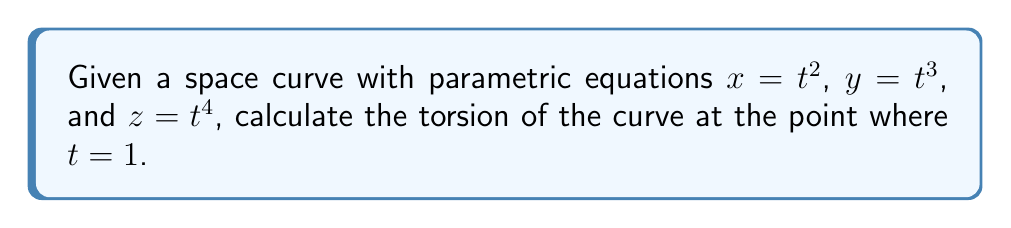Provide a solution to this math problem. To calculate the torsion of a space curve, we need to follow these steps:

1. Calculate the first, second, and third derivatives of the position vector $\mathbf{r}(t) = (x(t), y(t), z(t))$:

   $\mathbf{r}'(t) = (2t, 3t^2, 4t^3)$
   $\mathbf{r}''(t) = (2, 6t, 12t^2)$
   $\mathbf{r}'''(t) = (0, 6, 24t)$

2. Calculate the cross product of $\mathbf{r}'(t)$ and $\mathbf{r}''(t)$:

   $\mathbf{r}'(t) \times \mathbf{r}''(t) = \begin{vmatrix}
   \mathbf{i} & \mathbf{j} & \mathbf{k} \\
   2t & 3t^2 & 4t^3 \\
   2 & 6t & 12t^2
   \end{vmatrix} = (36t^4 - 24t^3)\mathbf{i} - (24t^3 - 8t)\mathbf{j} + (12t^2 - 18t^3)\mathbf{k}$

3. Calculate the scalar triple product $[\mathbf{r}'(t), \mathbf{r}''(t), \mathbf{r}'''(t)]$:

   $[\mathbf{r}'(t), \mathbf{r}''(t), \mathbf{r}'''(t)] = \mathbf{r}'''(t) \cdot (\mathbf{r}'(t) \times \mathbf{r}''(t))$
   
   $= (0, 6, 24t) \cdot ((36t^4 - 24t^3), -(24t^3 - 8t), (12t^2 - 18t^3))$
   
   $= 6(-(24t^3 - 8t)) + 24t(12t^2 - 18t^3)$
   
   $= -144t^3 + 48t + 288t^3 - 432t^4$
   
   $= -432t^4 + 144t^3 + 48t$

4. Calculate the magnitude of $\mathbf{r}'(t) \times \mathbf{r}''(t)$:

   $|\mathbf{r}'(t) \times \mathbf{r}''(t)| = \sqrt{(36t^4 - 24t^3)^2 + (24t^3 - 8t)^2 + (12t^2 - 18t^3)^2}$

5. The torsion formula is:

   $\tau(t) = \frac{[\mathbf{r}'(t), \mathbf{r}''(t), \mathbf{r}'''(t)]}{|\mathbf{r}'(t) \times \mathbf{r}''(t)|^2}$

6. Substitute $t = 1$ into the formula:

   $\tau(1) = \frac{-432 + 144 + 48}{((36 - 24)^2 + (24 - 8)^2 + (12 - 18)^2)^2}$
   
   $= \frac{-240}{(12^2 + 16^2 + (-6)^2)^2}$
   
   $= \frac{-240}{(144 + 256 + 36)^2}$
   
   $= \frac{-240}{436^2}$
   
   $= -\frac{240}{190096}$
   
   $= -\frac{5}{3960}$
Answer: $-\frac{5}{3960}$ 